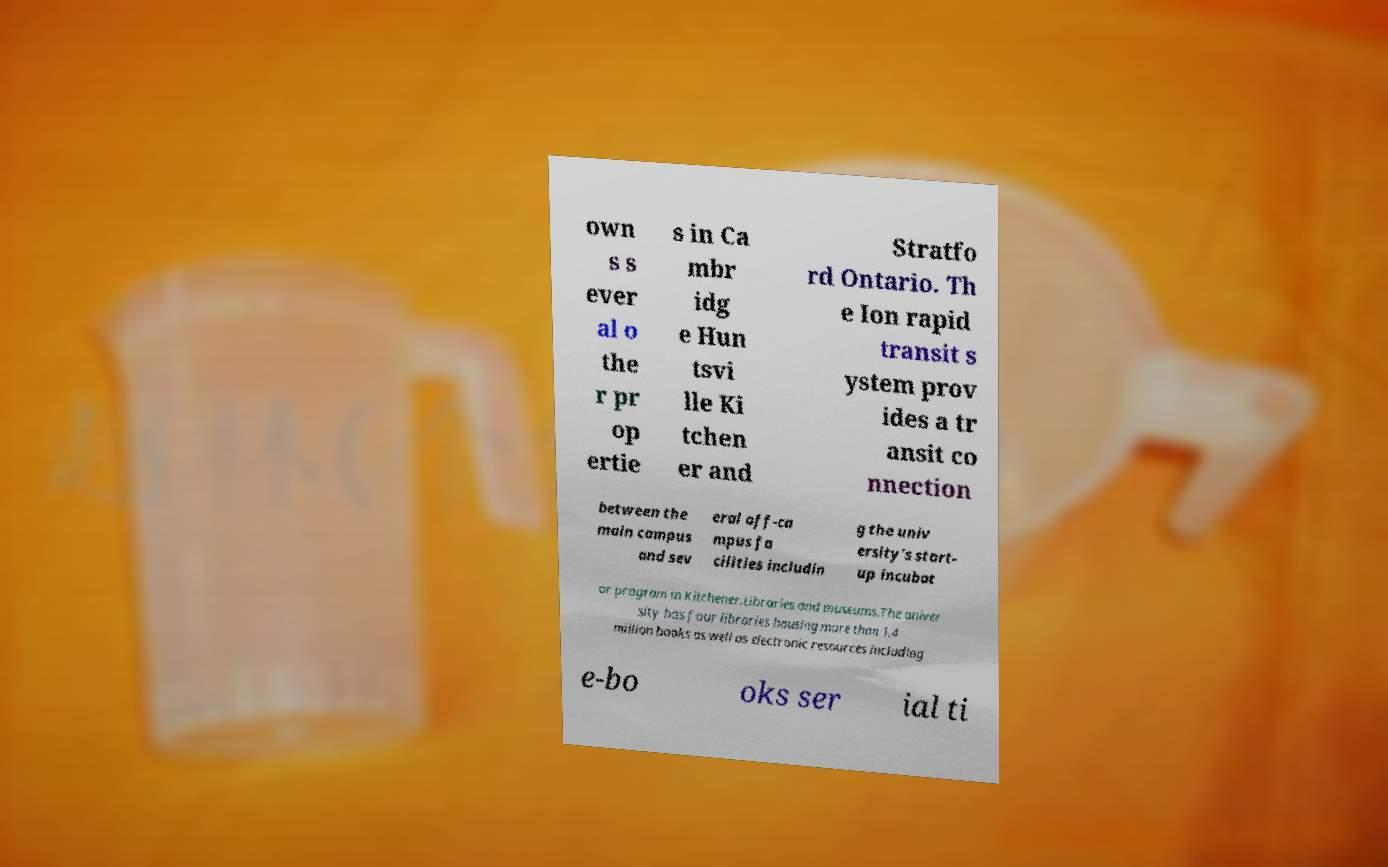Can you accurately transcribe the text from the provided image for me? own s s ever al o the r pr op ertie s in Ca mbr idg e Hun tsvi lle Ki tchen er and Stratfo rd Ontario. Th e Ion rapid transit s ystem prov ides a tr ansit co nnection between the main campus and sev eral off-ca mpus fa cilities includin g the univ ersity's start- up incubat or program in Kitchener.Libraries and museums.The univer sity has four libraries housing more than 1.4 million books as well as electronic resources including e-bo oks ser ial ti 